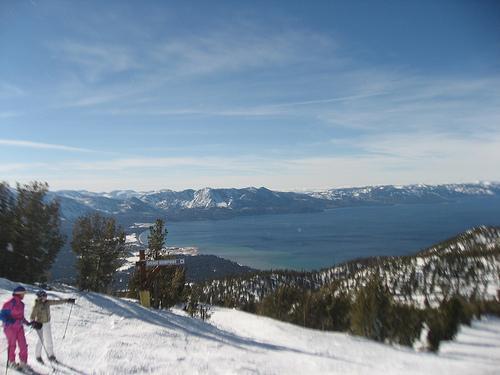How many women are on the hill side?
Give a very brief answer. 2. 